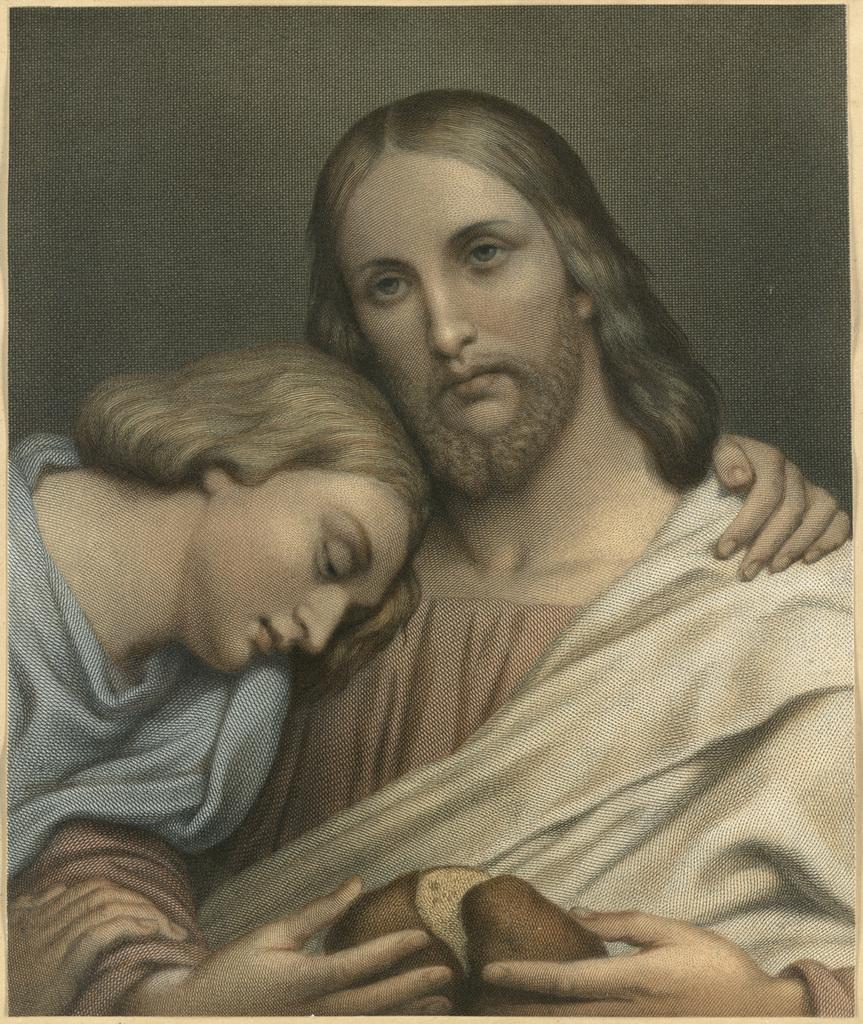Could you give a brief overview of what you see in this image? In this picture we can observe two members. One of them was a woman and the other was a man. 